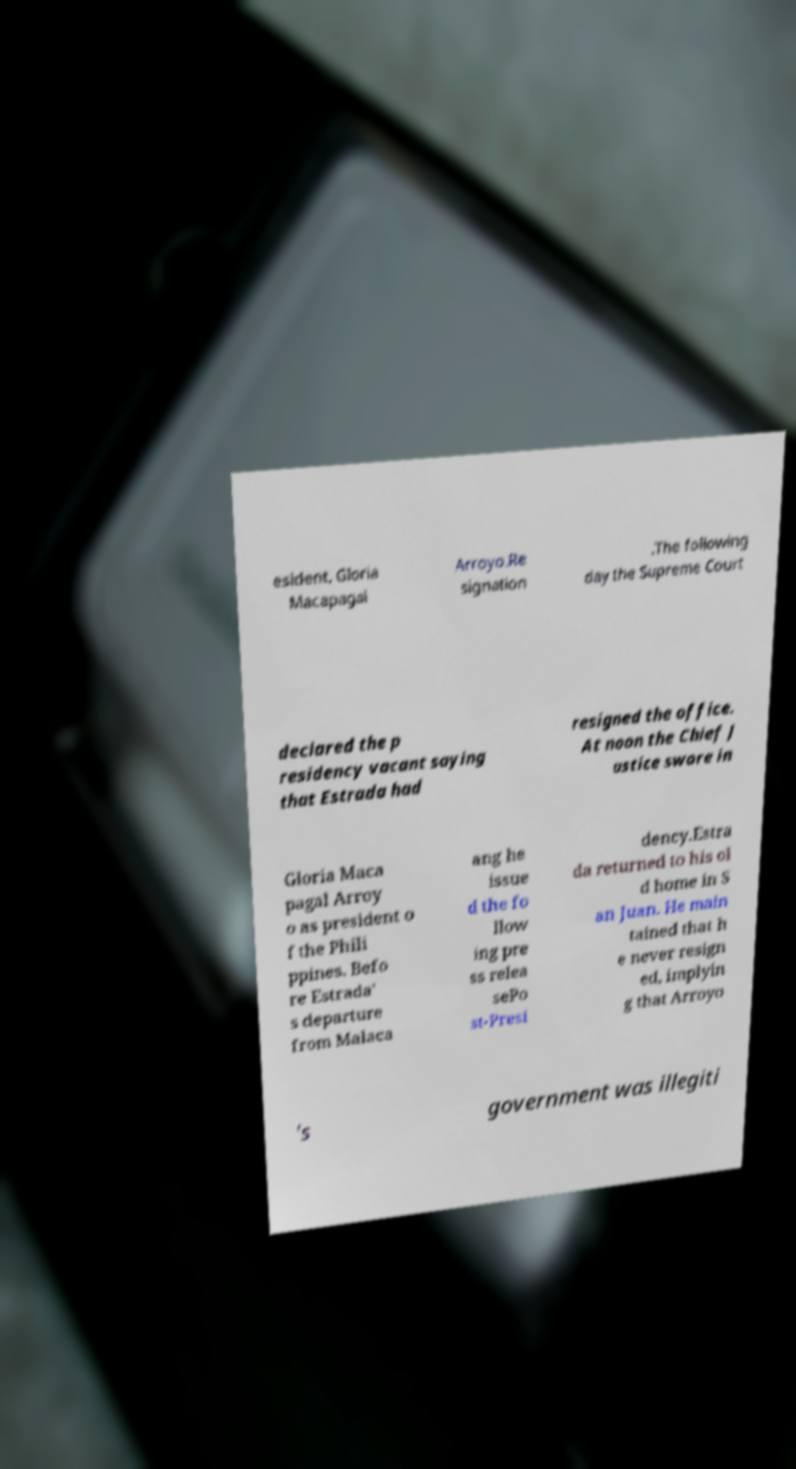For documentation purposes, I need the text within this image transcribed. Could you provide that? esident, Gloria Macapagal Arroyo.Re signation .The following day the Supreme Court declared the p residency vacant saying that Estrada had resigned the office. At noon the Chief J ustice swore in Gloria Maca pagal Arroy o as president o f the Phili ppines. Befo re Estrada' s departure from Malaca ang he issue d the fo llow ing pre ss relea sePo st-Presi dency.Estra da returned to his ol d home in S an Juan. He main tained that h e never resign ed, implyin g that Arroyo 's government was illegiti 